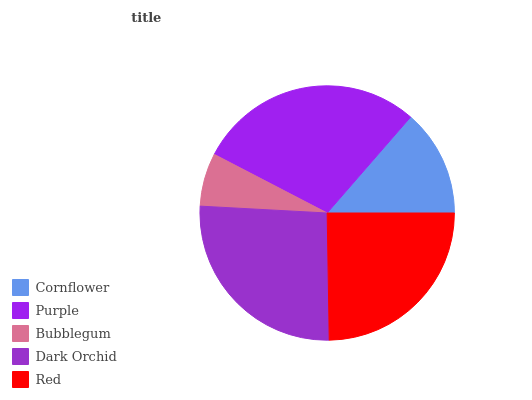Is Bubblegum the minimum?
Answer yes or no. Yes. Is Purple the maximum?
Answer yes or no. Yes. Is Purple the minimum?
Answer yes or no. No. Is Bubblegum the maximum?
Answer yes or no. No. Is Purple greater than Bubblegum?
Answer yes or no. Yes. Is Bubblegum less than Purple?
Answer yes or no. Yes. Is Bubblegum greater than Purple?
Answer yes or no. No. Is Purple less than Bubblegum?
Answer yes or no. No. Is Red the high median?
Answer yes or no. Yes. Is Red the low median?
Answer yes or no. Yes. Is Purple the high median?
Answer yes or no. No. Is Cornflower the low median?
Answer yes or no. No. 